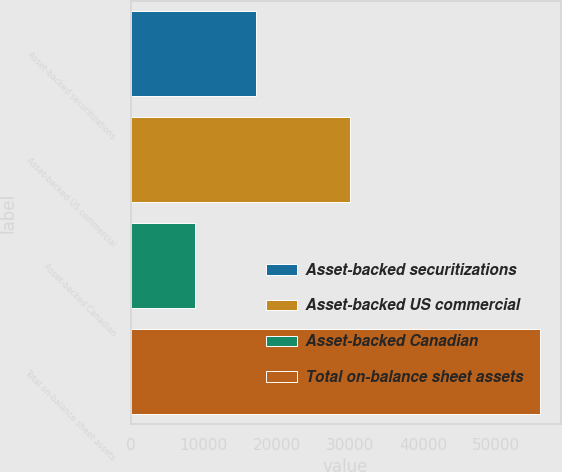Convert chart to OTSL. <chart><loc_0><loc_0><loc_500><loc_500><bar_chart><fcel>Asset-backed securitizations<fcel>Asset-backed US commercial<fcel>Asset-backed Canadian<fcel>Total on-balance sheet assets<nl><fcel>17191<fcel>30012<fcel>8779<fcel>55982<nl></chart> 